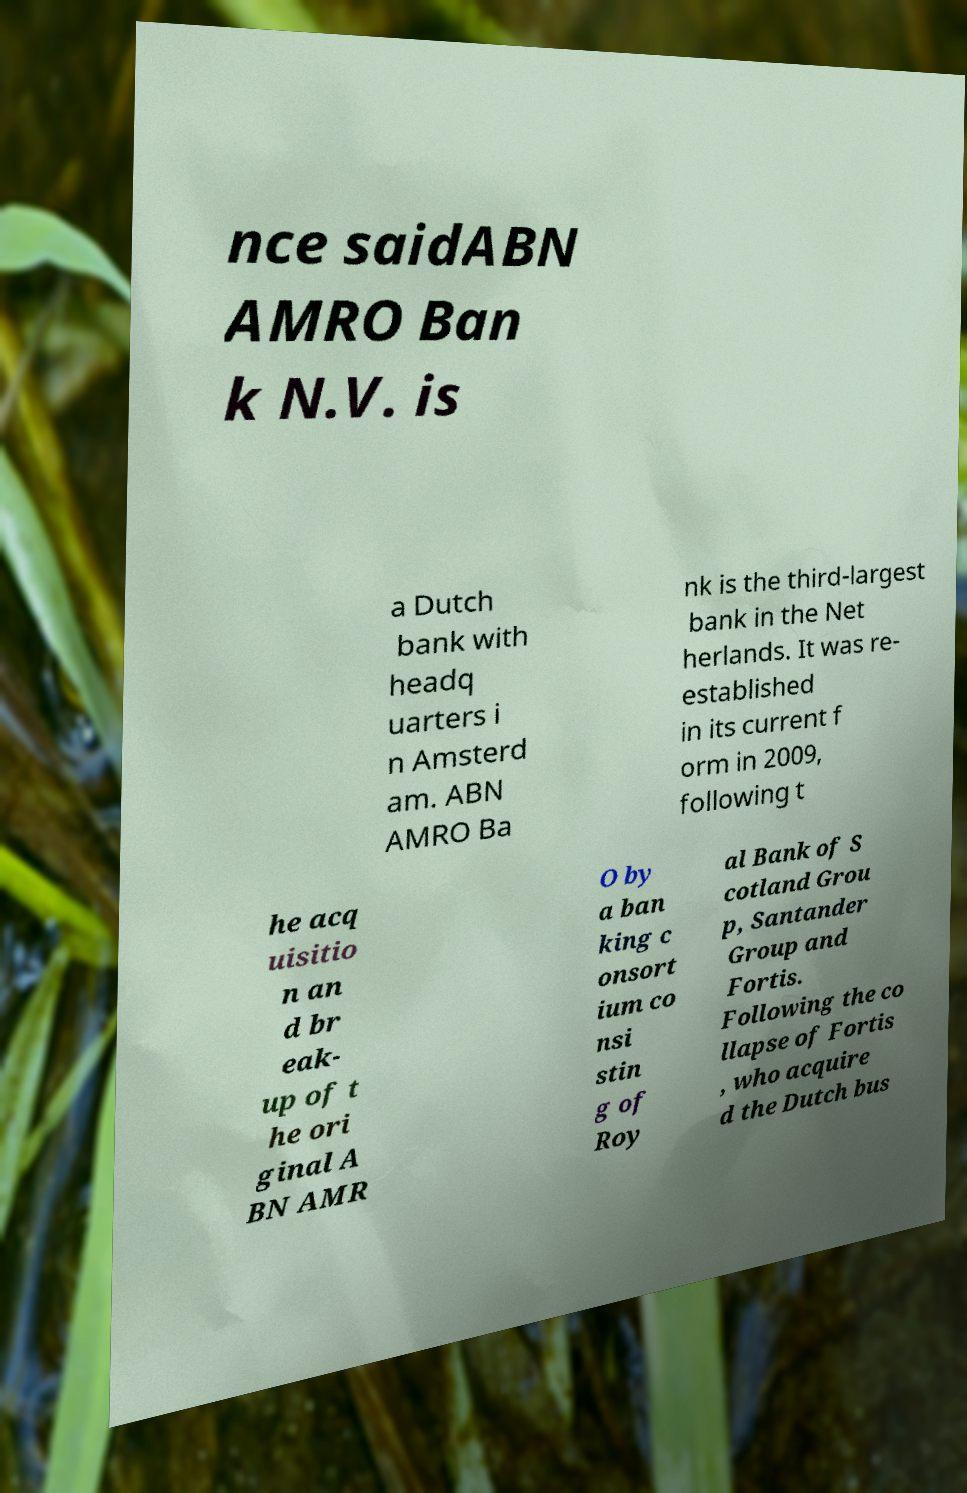Please read and relay the text visible in this image. What does it say? nce saidABN AMRO Ban k N.V. is a Dutch bank with headq uarters i n Amsterd am. ABN AMRO Ba nk is the third-largest bank in the Net herlands. It was re- established in its current f orm in 2009, following t he acq uisitio n an d br eak- up of t he ori ginal A BN AMR O by a ban king c onsort ium co nsi stin g of Roy al Bank of S cotland Grou p, Santander Group and Fortis. Following the co llapse of Fortis , who acquire d the Dutch bus 